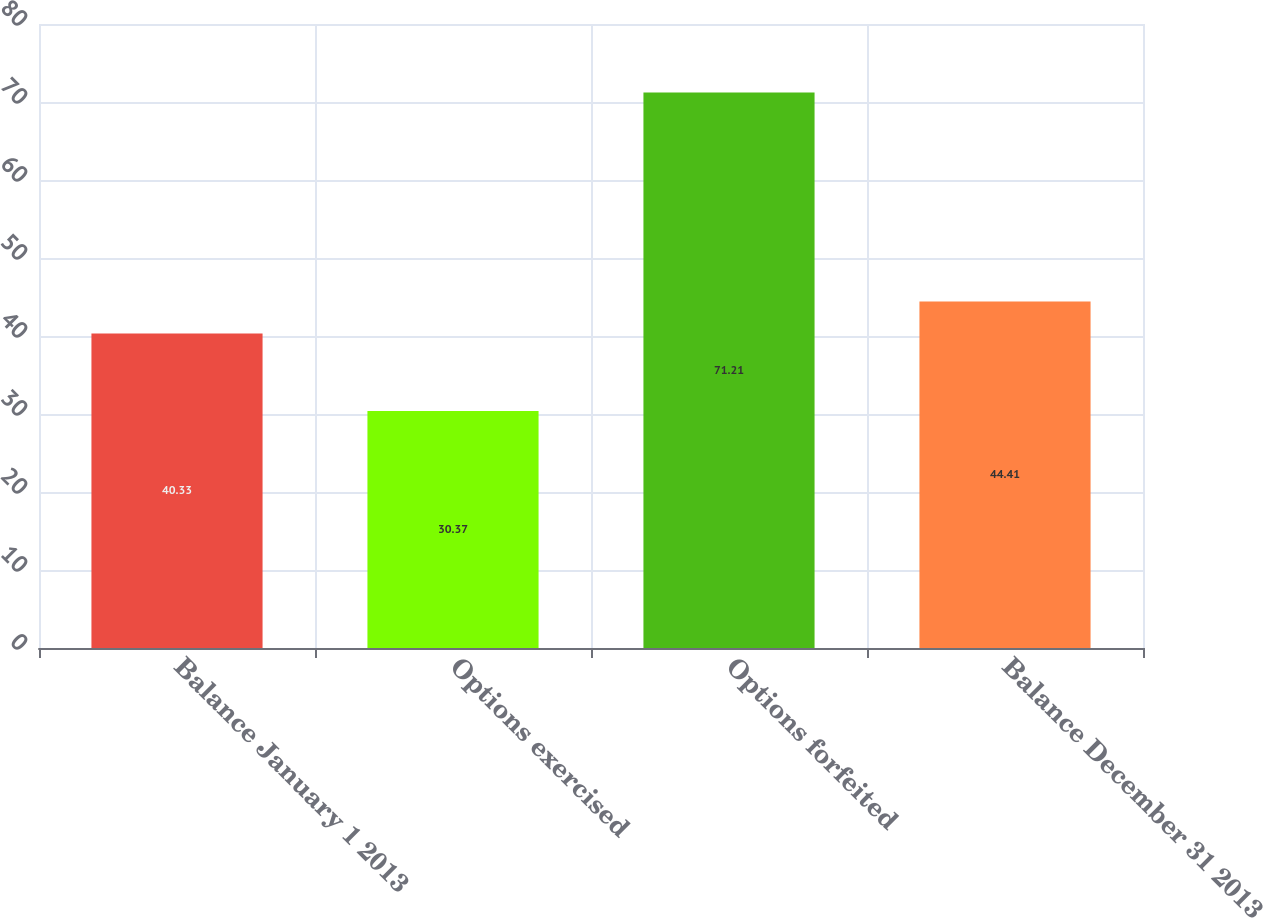<chart> <loc_0><loc_0><loc_500><loc_500><bar_chart><fcel>Balance January 1 2013<fcel>Options exercised<fcel>Options forfeited<fcel>Balance December 31 2013<nl><fcel>40.33<fcel>30.37<fcel>71.21<fcel>44.41<nl></chart> 